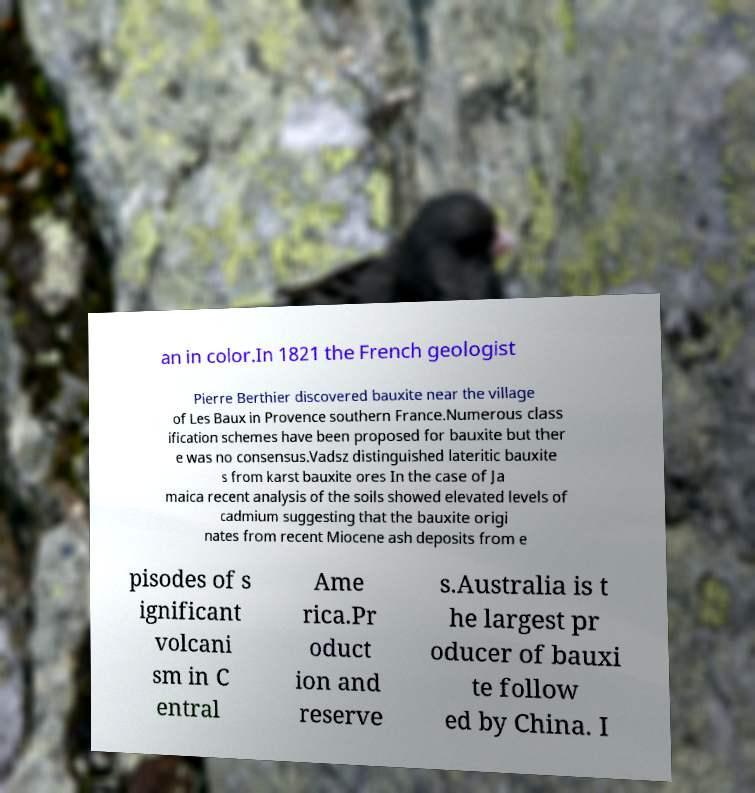Can you accurately transcribe the text from the provided image for me? an in color.In 1821 the French geologist Pierre Berthier discovered bauxite near the village of Les Baux in Provence southern France.Numerous class ification schemes have been proposed for bauxite but ther e was no consensus.Vadsz distinguished lateritic bauxite s from karst bauxite ores In the case of Ja maica recent analysis of the soils showed elevated levels of cadmium suggesting that the bauxite origi nates from recent Miocene ash deposits from e pisodes of s ignificant volcani sm in C entral Ame rica.Pr oduct ion and reserve s.Australia is t he largest pr oducer of bauxi te follow ed by China. I 